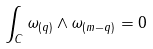<formula> <loc_0><loc_0><loc_500><loc_500>\int _ { C } \omega _ { ( q ) } \wedge \omega _ { ( m - q ) } = 0</formula> 